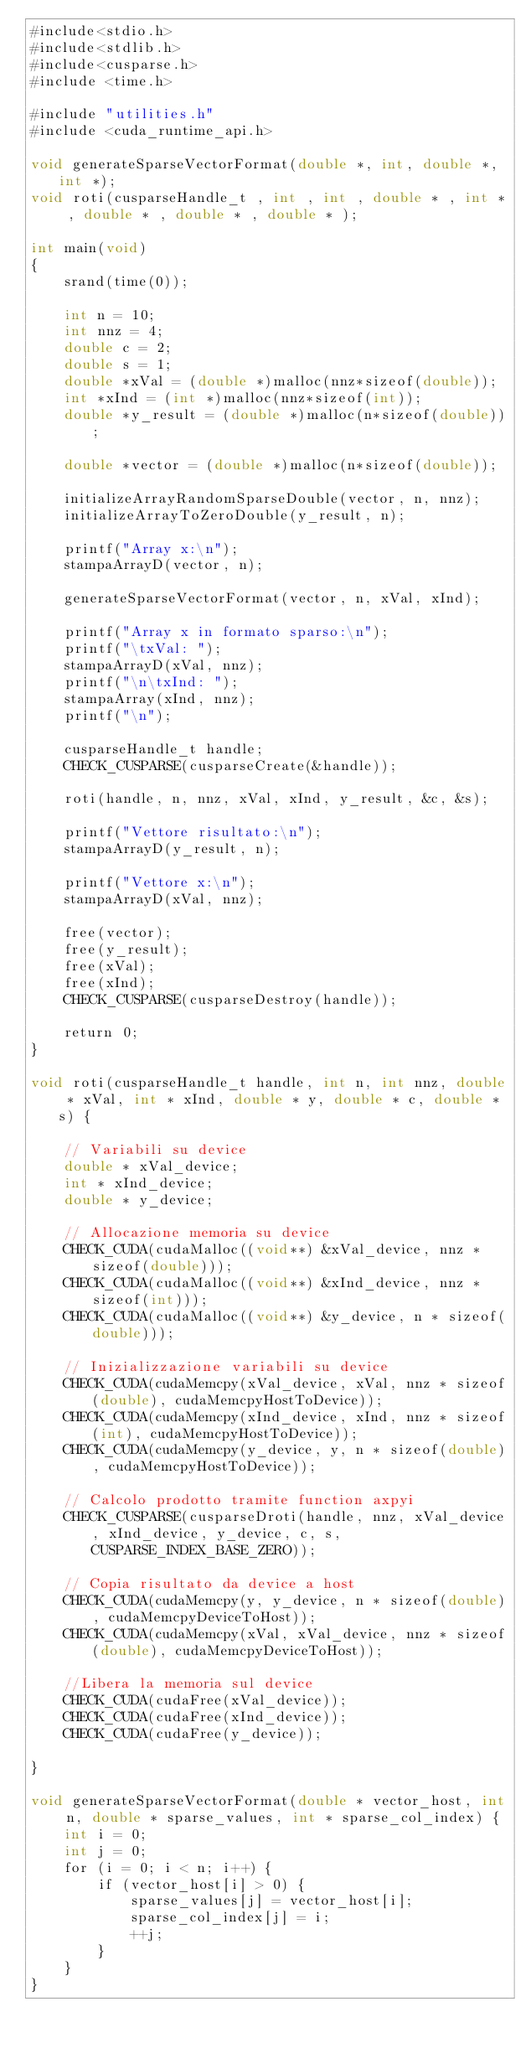<code> <loc_0><loc_0><loc_500><loc_500><_Cuda_>#include<stdio.h>
#include<stdlib.h>
#include<cusparse.h>
#include <time.h>

#include "utilities.h"
#include <cuda_runtime_api.h>

void generateSparseVectorFormat(double *, int, double *, int *);
void roti(cusparseHandle_t , int , int , double * , int * , double * , double * , double * );

int main(void)
{
    srand(time(0));

    int n = 10;
    int nnz = 4;
    double c = 2;
    double s = 1;
    double *xVal = (double *)malloc(nnz*sizeof(double));
    int *xInd = (int *)malloc(nnz*sizeof(int));
    double *y_result = (double *)malloc(n*sizeof(double));

    double *vector = (double *)malloc(n*sizeof(double));

    initializeArrayRandomSparseDouble(vector, n, nnz);
    initializeArrayToZeroDouble(y_result, n);

    printf("Array x:\n");
    stampaArrayD(vector, n);

    generateSparseVectorFormat(vector, n, xVal, xInd);

    printf("Array x in formato sparso:\n");
    printf("\txVal: ");
    stampaArrayD(xVal, nnz);
    printf("\n\txInd: ");
    stampaArray(xInd, nnz);
    printf("\n");

    cusparseHandle_t handle;
    CHECK_CUSPARSE(cusparseCreate(&handle));

    roti(handle, n, nnz, xVal, xInd, y_result, &c, &s);

    printf("Vettore risultato:\n");
    stampaArrayD(y_result, n);

    printf("Vettore x:\n");
    stampaArrayD(xVal, nnz);

    free(vector);
    free(y_result);
    free(xVal);
    free(xInd);
    CHECK_CUSPARSE(cusparseDestroy(handle));

    return 0;
}

void roti(cusparseHandle_t handle, int n, int nnz, double * xVal, int * xInd, double * y, double * c, double * s) {

    // Variabili su device
    double * xVal_device;
    int * xInd_device;
    double * y_device;

    // Allocazione memoria su device
    CHECK_CUDA(cudaMalloc((void**) &xVal_device, nnz * sizeof(double)));
    CHECK_CUDA(cudaMalloc((void**) &xInd_device, nnz * sizeof(int)));
    CHECK_CUDA(cudaMalloc((void**) &y_device, n * sizeof(double)));

    // Inizializzazione variabili su device
    CHECK_CUDA(cudaMemcpy(xVal_device, xVal, nnz * sizeof(double), cudaMemcpyHostToDevice));
    CHECK_CUDA(cudaMemcpy(xInd_device, xInd, nnz * sizeof(int), cudaMemcpyHostToDevice));
    CHECK_CUDA(cudaMemcpy(y_device, y, n * sizeof(double), cudaMemcpyHostToDevice));

    // Calcolo prodotto tramite function axpyi
    CHECK_CUSPARSE(cusparseDroti(handle, nnz, xVal_device, xInd_device, y_device, c, s, CUSPARSE_INDEX_BASE_ZERO));

    // Copia risultato da device a host
    CHECK_CUDA(cudaMemcpy(y, y_device, n * sizeof(double), cudaMemcpyDeviceToHost));
    CHECK_CUDA(cudaMemcpy(xVal, xVal_device, nnz * sizeof(double), cudaMemcpyDeviceToHost));

    //Libera la memoria sul device
    CHECK_CUDA(cudaFree(xVal_device));
    CHECK_CUDA(cudaFree(xInd_device));
    CHECK_CUDA(cudaFree(y_device));

}

void generateSparseVectorFormat(double * vector_host, int n, double * sparse_values, int * sparse_col_index) {
    int i = 0;
    int j = 0;
    for (i = 0; i < n; i++) {
        if (vector_host[i] > 0) {
            sparse_values[j] = vector_host[i];
            sparse_col_index[j] = i;
            ++j;
        }
    }
}</code> 